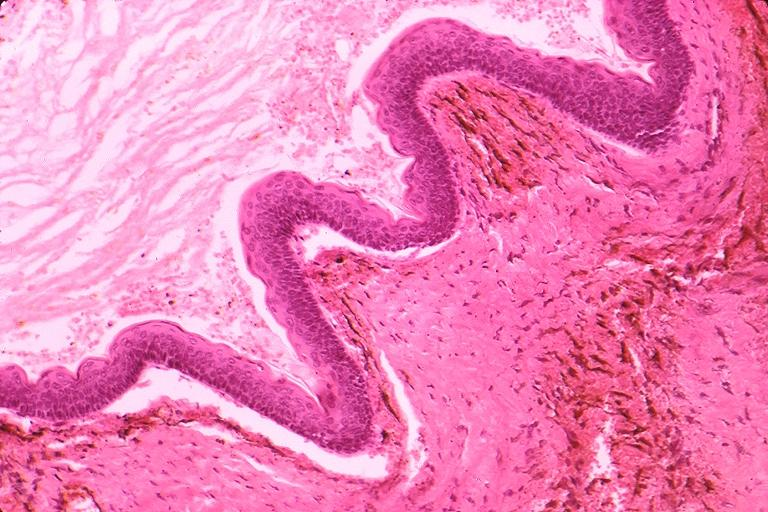s oral present?
Answer the question using a single word or phrase. Yes 